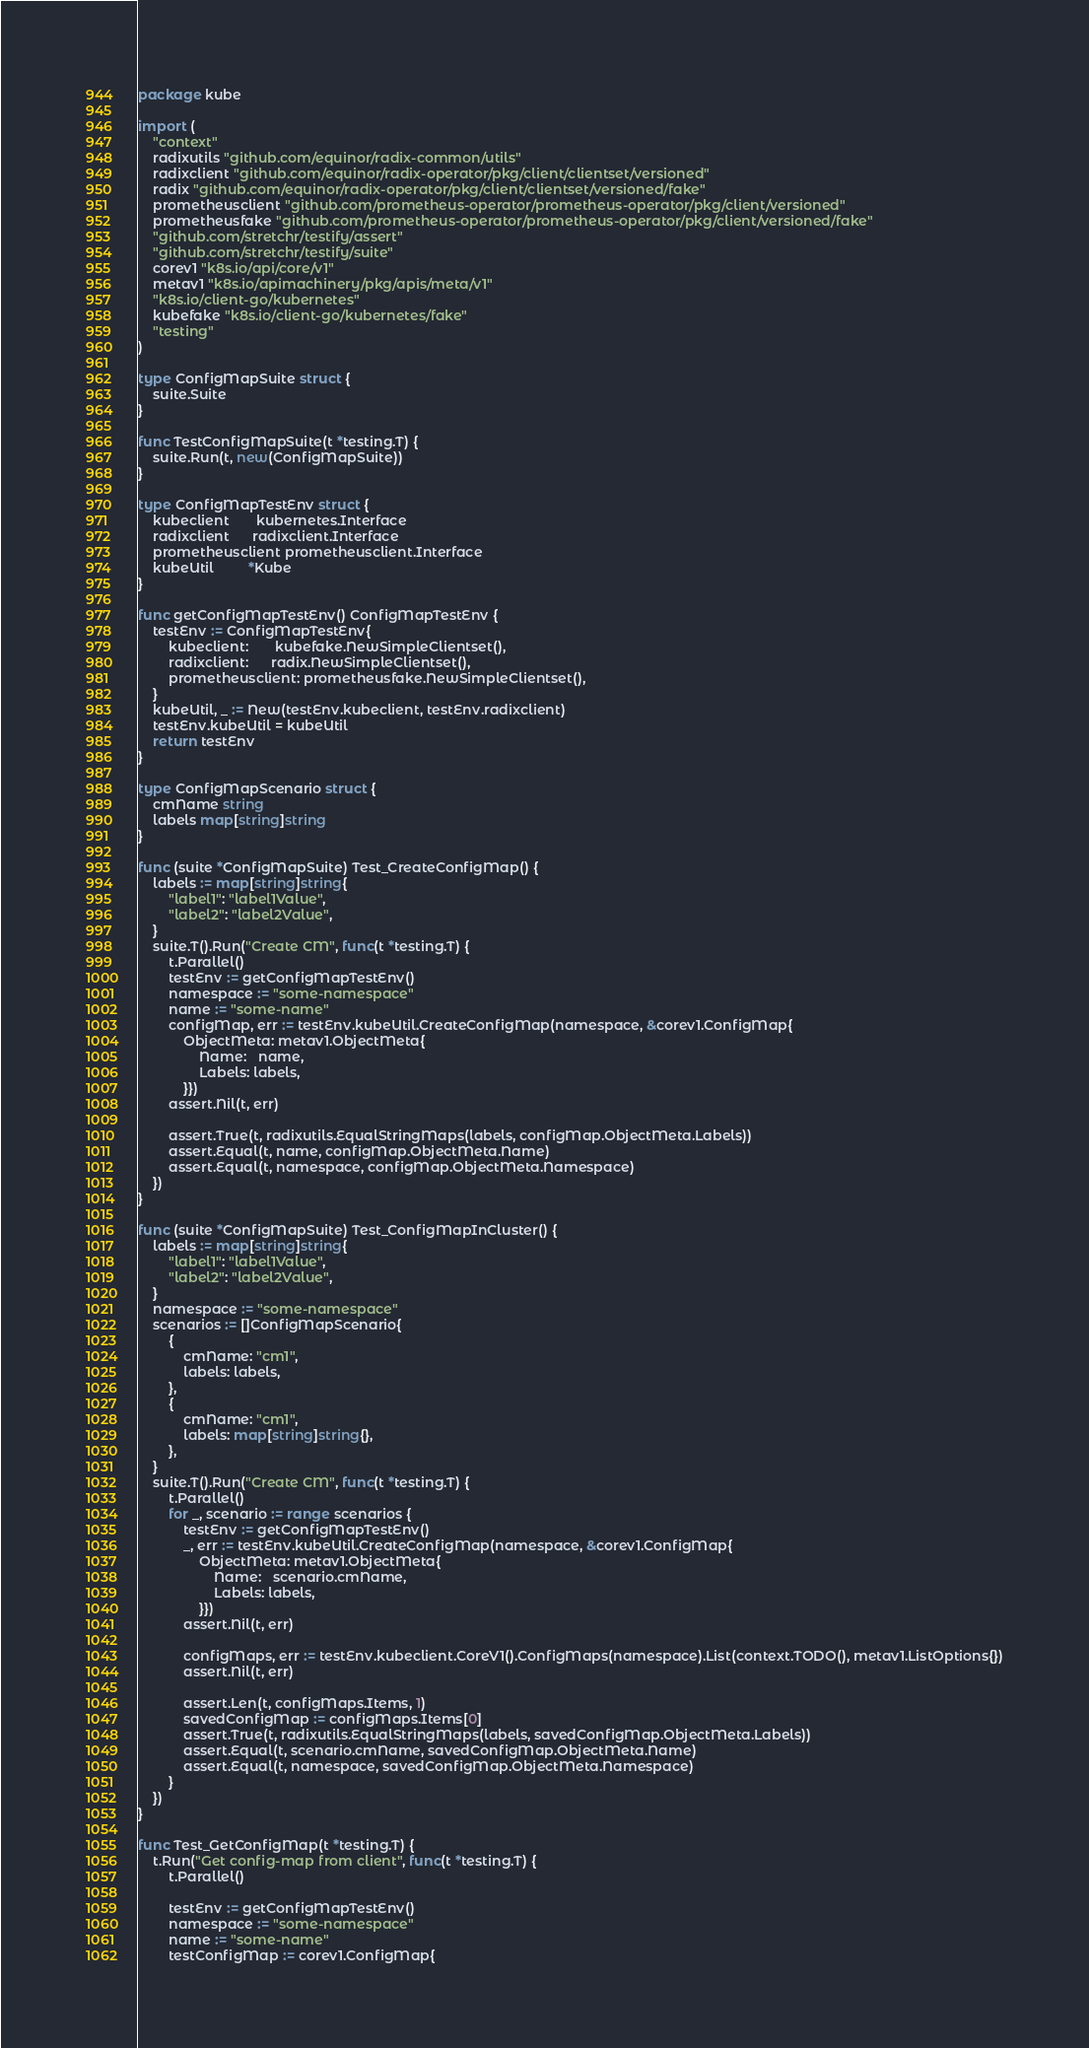Convert code to text. <code><loc_0><loc_0><loc_500><loc_500><_Go_>package kube

import (
	"context"
	radixutils "github.com/equinor/radix-common/utils"
	radixclient "github.com/equinor/radix-operator/pkg/client/clientset/versioned"
	radix "github.com/equinor/radix-operator/pkg/client/clientset/versioned/fake"
	prometheusclient "github.com/prometheus-operator/prometheus-operator/pkg/client/versioned"
	prometheusfake "github.com/prometheus-operator/prometheus-operator/pkg/client/versioned/fake"
	"github.com/stretchr/testify/assert"
	"github.com/stretchr/testify/suite"
	corev1 "k8s.io/api/core/v1"
	metav1 "k8s.io/apimachinery/pkg/apis/meta/v1"
	"k8s.io/client-go/kubernetes"
	kubefake "k8s.io/client-go/kubernetes/fake"
	"testing"
)

type ConfigMapSuite struct {
	suite.Suite
}

func TestConfigMapSuite(t *testing.T) {
	suite.Run(t, new(ConfigMapSuite))
}

type ConfigMapTestEnv struct {
	kubeclient       kubernetes.Interface
	radixclient      radixclient.Interface
	prometheusclient prometheusclient.Interface
	kubeUtil         *Kube
}

func getConfigMapTestEnv() ConfigMapTestEnv {
	testEnv := ConfigMapTestEnv{
		kubeclient:       kubefake.NewSimpleClientset(),
		radixclient:      radix.NewSimpleClientset(),
		prometheusclient: prometheusfake.NewSimpleClientset(),
	}
	kubeUtil, _ := New(testEnv.kubeclient, testEnv.radixclient)
	testEnv.kubeUtil = kubeUtil
	return testEnv
}

type ConfigMapScenario struct {
	cmName string
	labels map[string]string
}

func (suite *ConfigMapSuite) Test_CreateConfigMap() {
	labels := map[string]string{
		"label1": "label1Value",
		"label2": "label2Value",
	}
	suite.T().Run("Create CM", func(t *testing.T) {
		t.Parallel()
		testEnv := getConfigMapTestEnv()
		namespace := "some-namespace"
		name := "some-name"
		configMap, err := testEnv.kubeUtil.CreateConfigMap(namespace, &corev1.ConfigMap{
			ObjectMeta: metav1.ObjectMeta{
				Name:   name,
				Labels: labels,
			}})
		assert.Nil(t, err)

		assert.True(t, radixutils.EqualStringMaps(labels, configMap.ObjectMeta.Labels))
		assert.Equal(t, name, configMap.ObjectMeta.Name)
		assert.Equal(t, namespace, configMap.ObjectMeta.Namespace)
	})
}

func (suite *ConfigMapSuite) Test_ConfigMapInCluster() {
	labels := map[string]string{
		"label1": "label1Value",
		"label2": "label2Value",
	}
	namespace := "some-namespace"
	scenarios := []ConfigMapScenario{
		{
			cmName: "cm1",
			labels: labels,
		},
		{
			cmName: "cm1",
			labels: map[string]string{},
		},
	}
	suite.T().Run("Create CM", func(t *testing.T) {
		t.Parallel()
		for _, scenario := range scenarios {
			testEnv := getConfigMapTestEnv()
			_, err := testEnv.kubeUtil.CreateConfigMap(namespace, &corev1.ConfigMap{
				ObjectMeta: metav1.ObjectMeta{
					Name:   scenario.cmName,
					Labels: labels,
				}})
			assert.Nil(t, err)

			configMaps, err := testEnv.kubeclient.CoreV1().ConfigMaps(namespace).List(context.TODO(), metav1.ListOptions{})
			assert.Nil(t, err)

			assert.Len(t, configMaps.Items, 1)
			savedConfigMap := configMaps.Items[0]
			assert.True(t, radixutils.EqualStringMaps(labels, savedConfigMap.ObjectMeta.Labels))
			assert.Equal(t, scenario.cmName, savedConfigMap.ObjectMeta.Name)
			assert.Equal(t, namespace, savedConfigMap.ObjectMeta.Namespace)
		}
	})
}

func Test_GetConfigMap(t *testing.T) {
	t.Run("Get config-map from client", func(t *testing.T) {
		t.Parallel()

		testEnv := getConfigMapTestEnv()
		namespace := "some-namespace"
		name := "some-name"
		testConfigMap := corev1.ConfigMap{</code> 